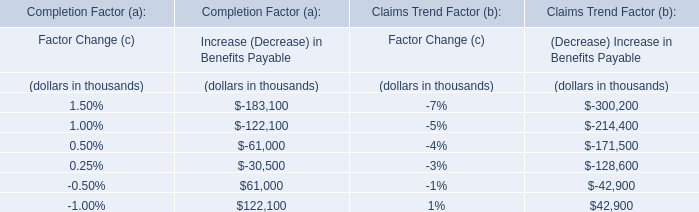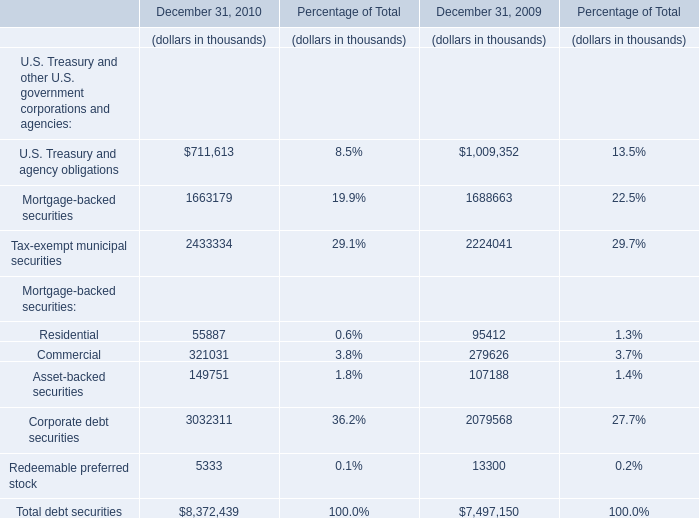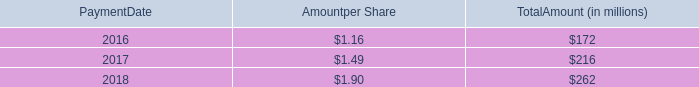What is the growing rate of the value of Tax-exempt municipal securities on December 31 in the year where the value of Asset-backed securities on December 31 is higher? 
Computations: ((2433334 - 2224041) / 2224041)
Answer: 0.0941. 